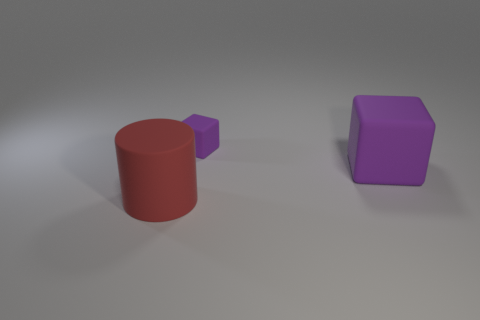Does the tiny rubber thing have the same shape as the large rubber object that is on the right side of the red thing?
Your response must be concise. Yes. What number of rubber things are behind the big red matte cylinder and in front of the tiny purple thing?
Give a very brief answer. 1. What number of purple things are large things or large blocks?
Provide a succinct answer. 1. Does the big rubber object on the right side of the small purple thing have the same color as the big thing to the left of the small purple thing?
Offer a very short reply. No. What is the color of the rubber object behind the purple block that is to the right of the purple matte object behind the big purple thing?
Offer a terse response. Purple. There is a matte cube on the right side of the small purple rubber block; is there a tiny purple object right of it?
Ensure brevity in your answer.  No. There is a large rubber thing that is behind the red thing; does it have the same shape as the small purple object?
Your response must be concise. Yes. Is there any other thing that is the same shape as the tiny purple rubber object?
Provide a short and direct response. Yes. What number of balls are either large matte objects or tiny yellow metal things?
Ensure brevity in your answer.  0. What number of matte cubes are there?
Your answer should be compact. 2. 